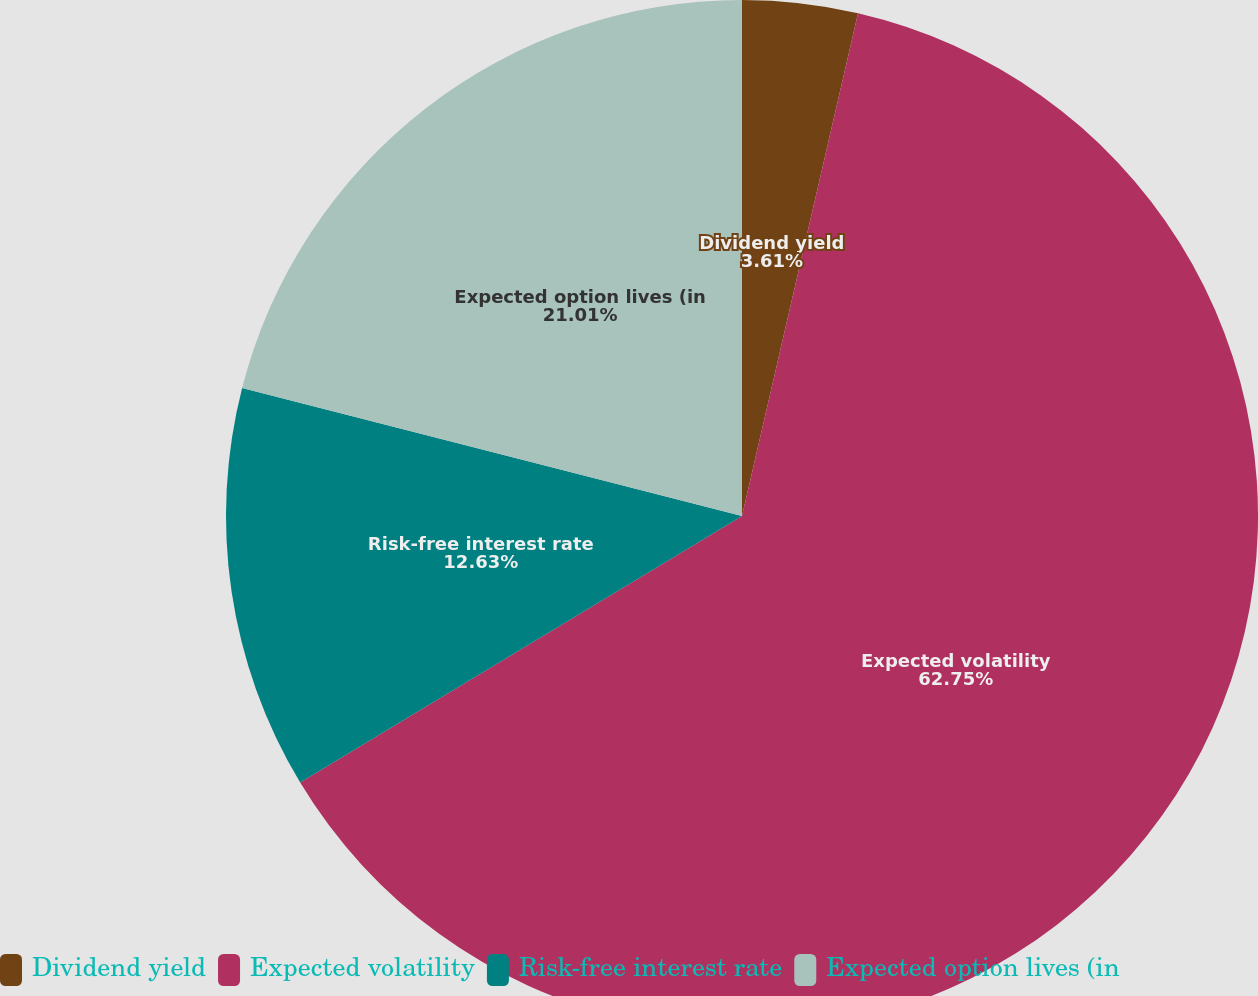<chart> <loc_0><loc_0><loc_500><loc_500><pie_chart><fcel>Dividend yield<fcel>Expected volatility<fcel>Risk-free interest rate<fcel>Expected option lives (in<nl><fcel>3.61%<fcel>62.75%<fcel>12.63%<fcel>21.01%<nl></chart> 